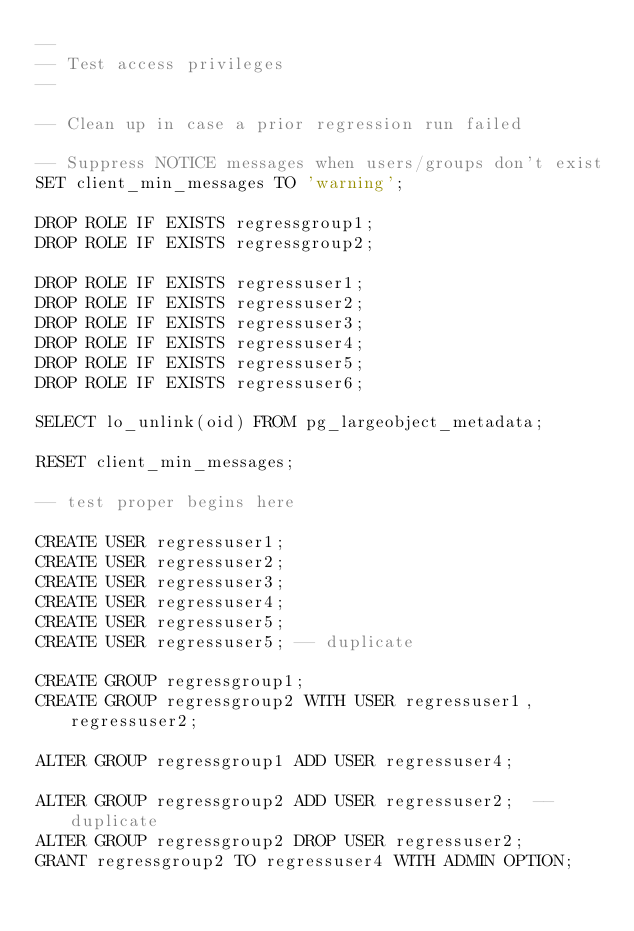<code> <loc_0><loc_0><loc_500><loc_500><_SQL_>--
-- Test access privileges
--

-- Clean up in case a prior regression run failed

-- Suppress NOTICE messages when users/groups don't exist
SET client_min_messages TO 'warning';

DROP ROLE IF EXISTS regressgroup1;
DROP ROLE IF EXISTS regressgroup2;

DROP ROLE IF EXISTS regressuser1;
DROP ROLE IF EXISTS regressuser2;
DROP ROLE IF EXISTS regressuser3;
DROP ROLE IF EXISTS regressuser4;
DROP ROLE IF EXISTS regressuser5;
DROP ROLE IF EXISTS regressuser6;

SELECT lo_unlink(oid) FROM pg_largeobject_metadata;

RESET client_min_messages;

-- test proper begins here

CREATE USER regressuser1;
CREATE USER regressuser2;
CREATE USER regressuser3;
CREATE USER regressuser4;
CREATE USER regressuser5;
CREATE USER regressuser5;	-- duplicate

CREATE GROUP regressgroup1;
CREATE GROUP regressgroup2 WITH USER regressuser1, regressuser2;

ALTER GROUP regressgroup1 ADD USER regressuser4;

ALTER GROUP regressgroup2 ADD USER regressuser2;	-- duplicate
ALTER GROUP regressgroup2 DROP USER regressuser2;
GRANT regressgroup2 TO regressuser4 WITH ADMIN OPTION;
</code> 